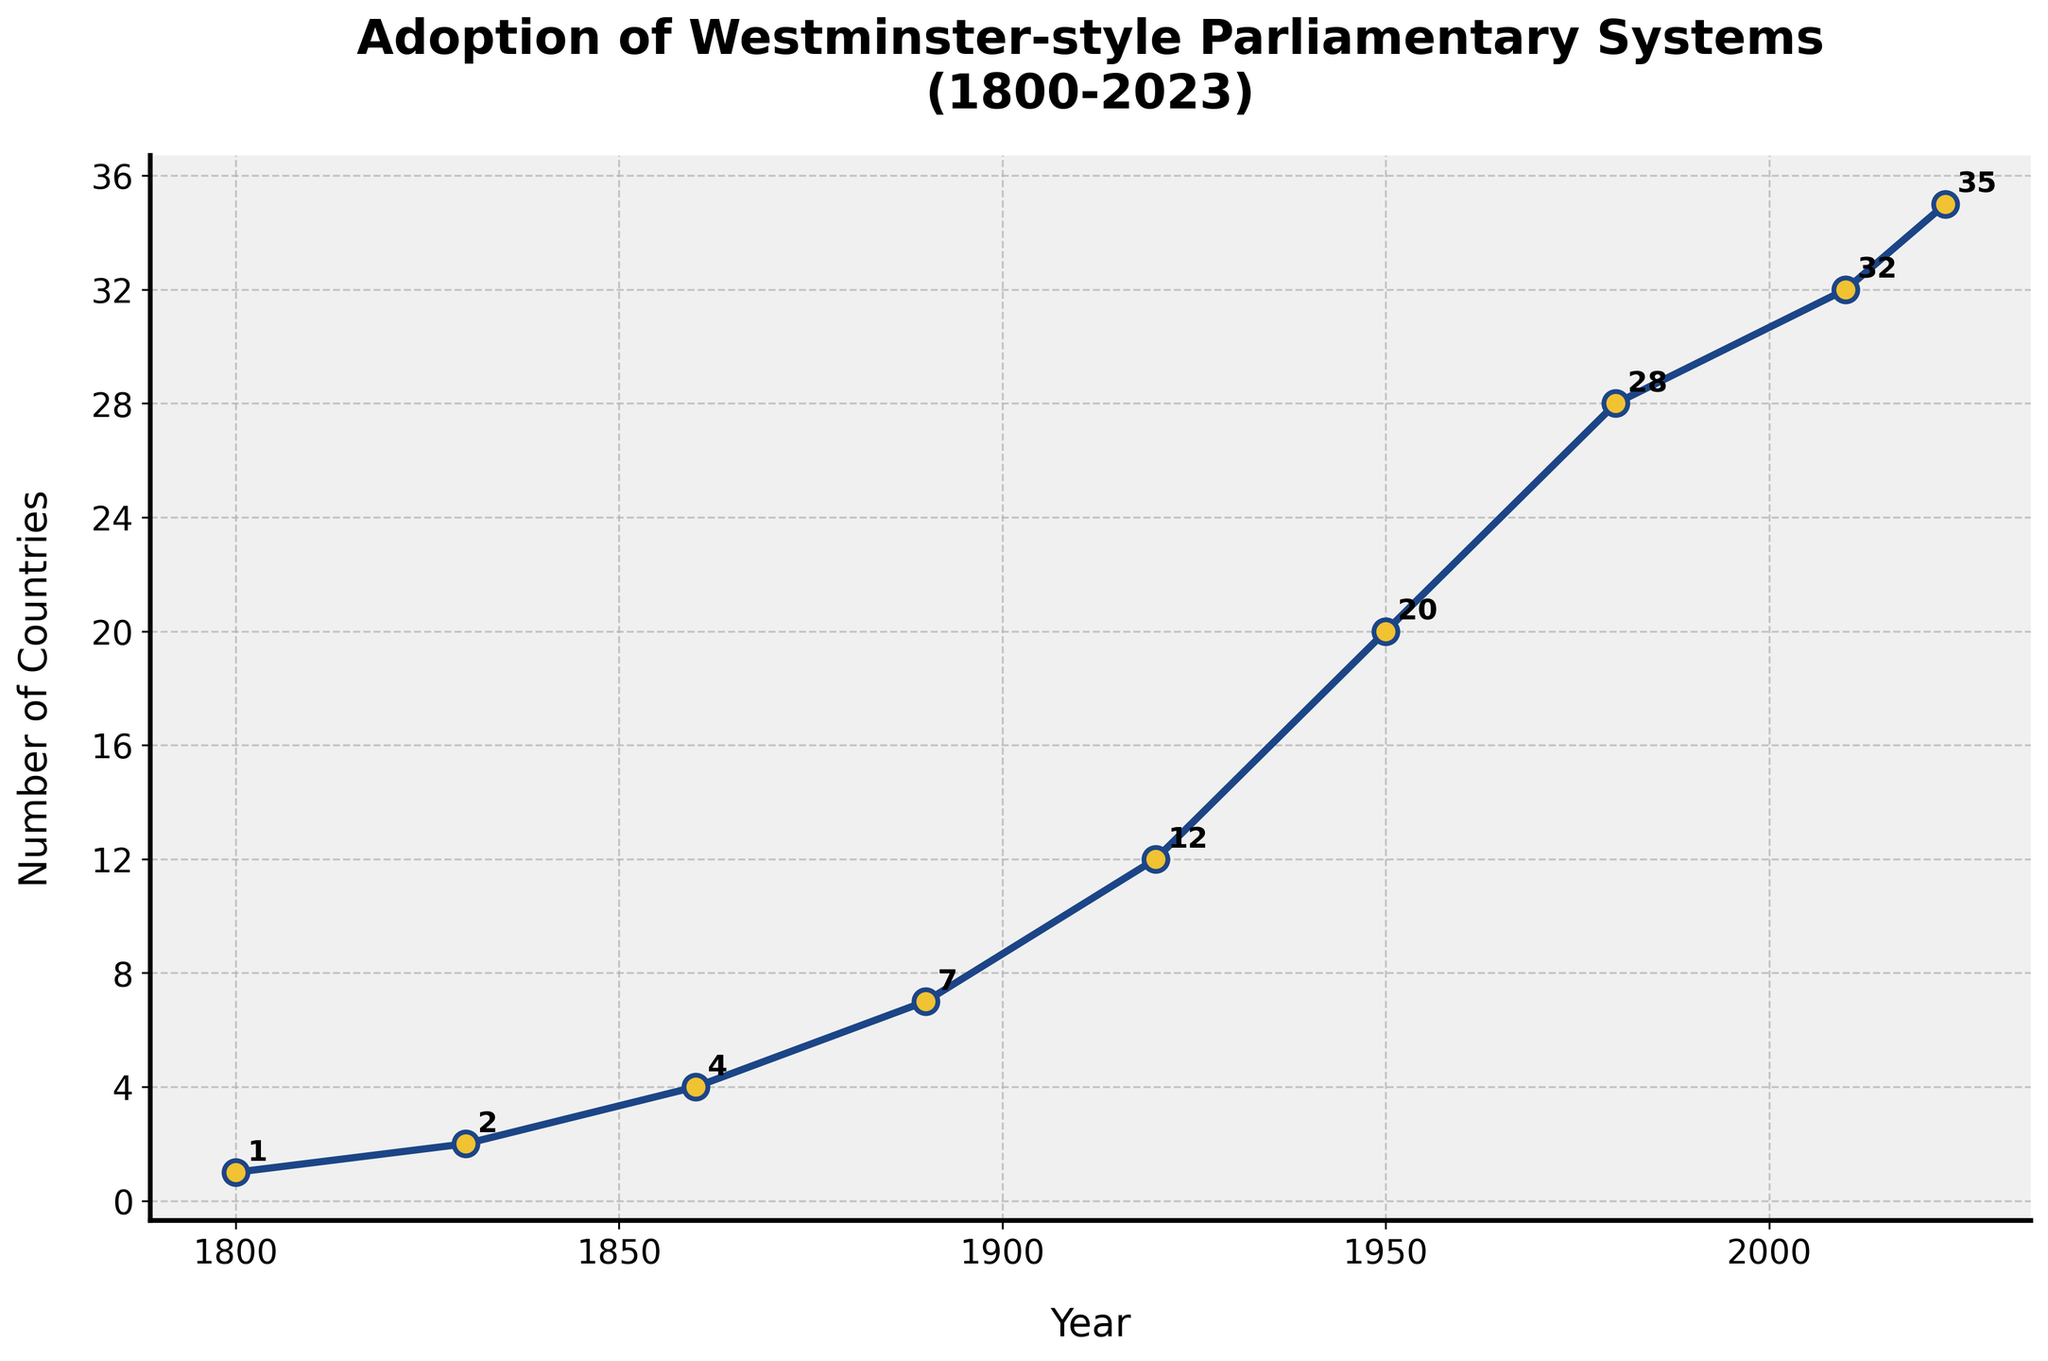What is the difference in the number of countries adopting Westminster-style parliamentary systems between 1950 and 1980? In 1950, there were 20 countries with Westminster-style parliamentary systems, and in 1980, there were 28. The difference is 28 - 20 = 8.
Answer: 8 How many countries adopted Westminster-style parliamentary systems between 1800 and 1830? In 1800, there was 1 country with such a system, and by 1830, there were 2 countries. The change is 2 - 1 = 1.
Answer: 1 What is the total number of new adoptions of Westminster-style systems from 1800 to 1920? Summing the increases: 1 (from 1800 to 1830) + 2 (from 1830 to 1860) + 3 (from 1860 to 1890) + 5 (from 1890 to 1920) gives a total of 11 new adoptions.
Answer: 11 Which decade saw the highest increase in the number of countries adopting Westminster-style parliamentary systems? Comparing the increases: 1 (1800 to 1830), 2 (1830 to 1860), 3 (1860 to 1890), 5 (1890 to 1920), 8 (1920 to 1950), 8 (1950 to 1980), 4 (1980 to 2010), and 3 (2010 to 2023), the greatest increase is 8, occurring twice (1920 to 1950 and 1950 to 1980).
Answer: 1920-1950 and 1950-1980 Visualize the difference in the number of adoptions between 1860 and 1920. In 1860, there were 4 countries, and by 1920, there were 12. The bars would show the increase from 4 to 12, which is 12 - 4 = 8.
Answer: 8 What is the average number of new adoptions per half-century from 1800 to 2023? Calculate the total number of adoptions (35 - 1 = 34) and then divide by the number of half-centuries (2023-1800)/50 = 4.46. So, 34/4.46 ≈ 7.62.
Answer: 7.62 Are any visual markers used to denote specific data points? Yes, each data point is marked with a circle ('o') and highlighted with a contrasting color.
Answer: Yes From the visual aspect of the chart, describe how the trend in adoptions of Westminster-style systems looks. The line starts slowly, rises more sharply around the mid-20th century, and continues to slope upward more gradually in recent years.
Answer: Increasing trend, sharp rise in mid-20th century What is the increment in the number of countries from 2010 to 2023? In 2010, there were 32 countries, and in 2023, there were 35, so the increment is 35 - 32 = 3.
Answer: 3 Which 30-year period shows the most significant increase in the number of adoptions? Comparing 30-year periods: 1830-1860 (2), 1860-1890 (3), 1890-1920 (5), 1920-1950 (8), 1950-1980 (8), 1980-2010 (4), the highest increase of 8 happens in two periods: 1920-1950 and 1950-1980.
Answer: 1920-1950 and 1950-1980 